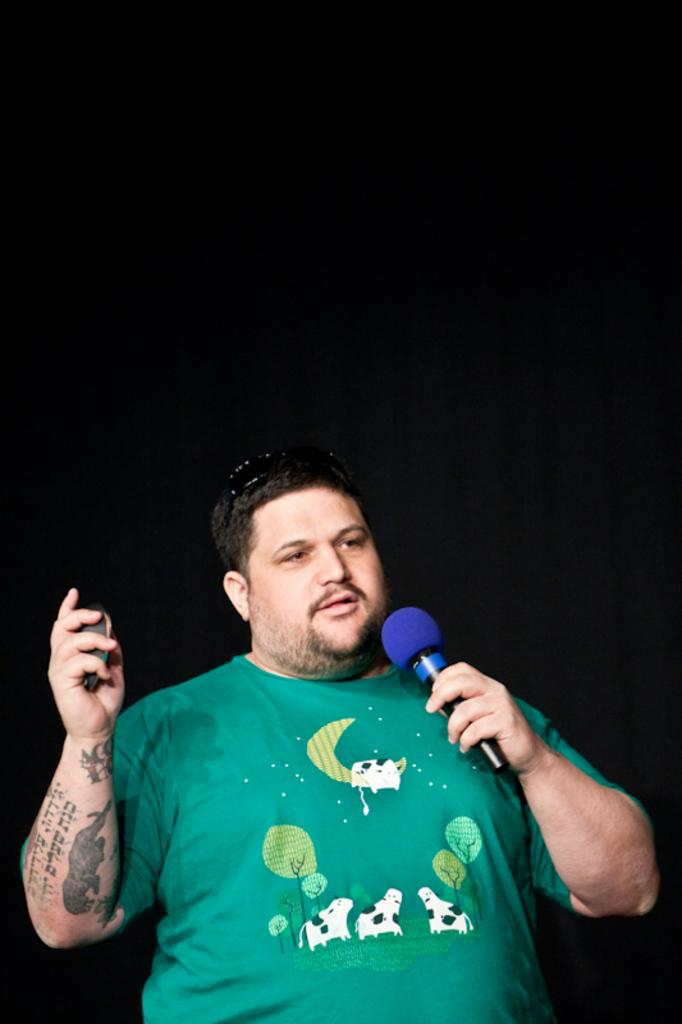What is the main subject of the image? The main subject of the image is a man. What is the man wearing in the image? The man is wearing a green t-shirt. What is the man holding in the image? The man is holding a microphone. What is the man doing in the image? The man is talking. Can you describe any additional features of the man in the image? A: The man has a tattoo on his hand. How many cats are present at the party in the image? There is no party or cats present in the image; it features a man holding a microphone and talking. 